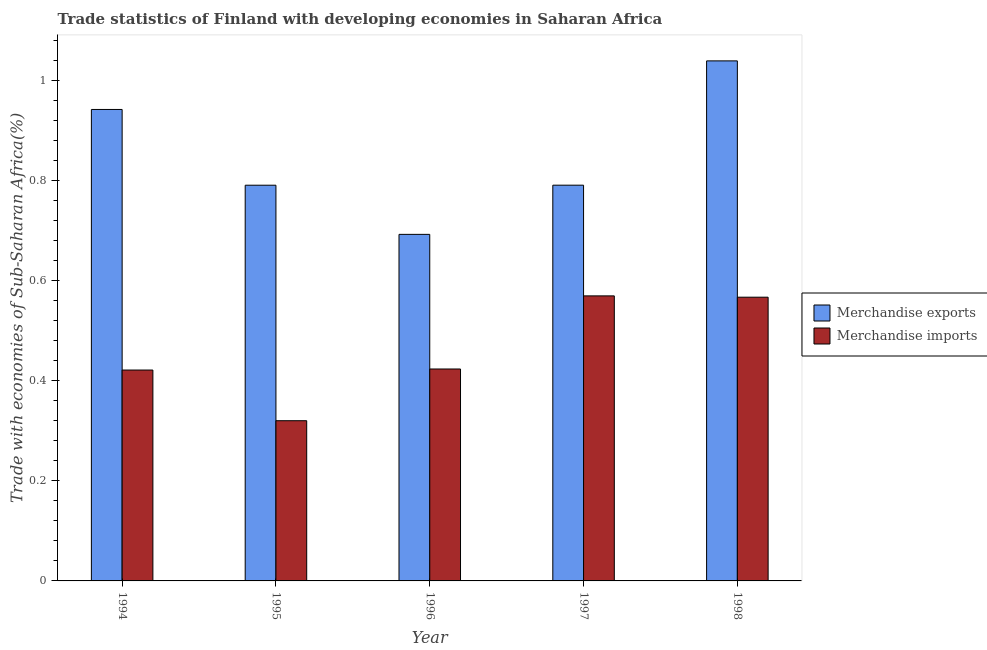How many different coloured bars are there?
Offer a terse response. 2. Are the number of bars on each tick of the X-axis equal?
Offer a very short reply. Yes. How many bars are there on the 4th tick from the right?
Your answer should be very brief. 2. What is the label of the 4th group of bars from the left?
Your response must be concise. 1997. What is the merchandise exports in 1996?
Make the answer very short. 0.69. Across all years, what is the maximum merchandise exports?
Your answer should be very brief. 1.04. Across all years, what is the minimum merchandise exports?
Your answer should be very brief. 0.69. What is the total merchandise imports in the graph?
Offer a terse response. 2.3. What is the difference between the merchandise exports in 1994 and that in 1996?
Provide a short and direct response. 0.25. What is the difference between the merchandise exports in 1996 and the merchandise imports in 1994?
Give a very brief answer. -0.25. What is the average merchandise exports per year?
Offer a terse response. 0.85. What is the ratio of the merchandise imports in 1995 to that in 1997?
Give a very brief answer. 0.56. Is the difference between the merchandise imports in 1994 and 1996 greater than the difference between the merchandise exports in 1994 and 1996?
Offer a very short reply. No. What is the difference between the highest and the second highest merchandise imports?
Offer a terse response. 0. What is the difference between the highest and the lowest merchandise exports?
Your response must be concise. 0.35. In how many years, is the merchandise imports greater than the average merchandise imports taken over all years?
Ensure brevity in your answer.  2. Is the sum of the merchandise imports in 1994 and 1996 greater than the maximum merchandise exports across all years?
Your answer should be very brief. Yes. What does the 2nd bar from the left in 1997 represents?
Keep it short and to the point. Merchandise imports. How many bars are there?
Keep it short and to the point. 10. How many years are there in the graph?
Your answer should be very brief. 5. Where does the legend appear in the graph?
Your answer should be very brief. Center right. How many legend labels are there?
Your answer should be very brief. 2. How are the legend labels stacked?
Give a very brief answer. Vertical. What is the title of the graph?
Provide a succinct answer. Trade statistics of Finland with developing economies in Saharan Africa. Does "constant 2005 US$" appear as one of the legend labels in the graph?
Your answer should be very brief. No. What is the label or title of the X-axis?
Make the answer very short. Year. What is the label or title of the Y-axis?
Ensure brevity in your answer.  Trade with economies of Sub-Saharan Africa(%). What is the Trade with economies of Sub-Saharan Africa(%) of Merchandise exports in 1994?
Your response must be concise. 0.94. What is the Trade with economies of Sub-Saharan Africa(%) of Merchandise imports in 1994?
Your answer should be very brief. 0.42. What is the Trade with economies of Sub-Saharan Africa(%) in Merchandise exports in 1995?
Your answer should be compact. 0.79. What is the Trade with economies of Sub-Saharan Africa(%) of Merchandise imports in 1995?
Your answer should be compact. 0.32. What is the Trade with economies of Sub-Saharan Africa(%) of Merchandise exports in 1996?
Ensure brevity in your answer.  0.69. What is the Trade with economies of Sub-Saharan Africa(%) in Merchandise imports in 1996?
Your answer should be very brief. 0.42. What is the Trade with economies of Sub-Saharan Africa(%) of Merchandise exports in 1997?
Your response must be concise. 0.79. What is the Trade with economies of Sub-Saharan Africa(%) of Merchandise imports in 1997?
Make the answer very short. 0.57. What is the Trade with economies of Sub-Saharan Africa(%) of Merchandise exports in 1998?
Give a very brief answer. 1.04. What is the Trade with economies of Sub-Saharan Africa(%) of Merchandise imports in 1998?
Ensure brevity in your answer.  0.57. Across all years, what is the maximum Trade with economies of Sub-Saharan Africa(%) in Merchandise exports?
Provide a short and direct response. 1.04. Across all years, what is the maximum Trade with economies of Sub-Saharan Africa(%) of Merchandise imports?
Your response must be concise. 0.57. Across all years, what is the minimum Trade with economies of Sub-Saharan Africa(%) in Merchandise exports?
Your answer should be compact. 0.69. Across all years, what is the minimum Trade with economies of Sub-Saharan Africa(%) in Merchandise imports?
Offer a terse response. 0.32. What is the total Trade with economies of Sub-Saharan Africa(%) of Merchandise exports in the graph?
Offer a terse response. 4.26. What is the total Trade with economies of Sub-Saharan Africa(%) of Merchandise imports in the graph?
Ensure brevity in your answer.  2.3. What is the difference between the Trade with economies of Sub-Saharan Africa(%) of Merchandise exports in 1994 and that in 1995?
Give a very brief answer. 0.15. What is the difference between the Trade with economies of Sub-Saharan Africa(%) in Merchandise imports in 1994 and that in 1995?
Provide a short and direct response. 0.1. What is the difference between the Trade with economies of Sub-Saharan Africa(%) in Merchandise exports in 1994 and that in 1996?
Offer a very short reply. 0.25. What is the difference between the Trade with economies of Sub-Saharan Africa(%) of Merchandise imports in 1994 and that in 1996?
Your response must be concise. -0. What is the difference between the Trade with economies of Sub-Saharan Africa(%) in Merchandise exports in 1994 and that in 1997?
Keep it short and to the point. 0.15. What is the difference between the Trade with economies of Sub-Saharan Africa(%) of Merchandise imports in 1994 and that in 1997?
Offer a terse response. -0.15. What is the difference between the Trade with economies of Sub-Saharan Africa(%) in Merchandise exports in 1994 and that in 1998?
Offer a terse response. -0.1. What is the difference between the Trade with economies of Sub-Saharan Africa(%) of Merchandise imports in 1994 and that in 1998?
Your answer should be very brief. -0.15. What is the difference between the Trade with economies of Sub-Saharan Africa(%) of Merchandise exports in 1995 and that in 1996?
Ensure brevity in your answer.  0.1. What is the difference between the Trade with economies of Sub-Saharan Africa(%) of Merchandise imports in 1995 and that in 1996?
Make the answer very short. -0.1. What is the difference between the Trade with economies of Sub-Saharan Africa(%) in Merchandise exports in 1995 and that in 1997?
Your response must be concise. -0. What is the difference between the Trade with economies of Sub-Saharan Africa(%) in Merchandise imports in 1995 and that in 1997?
Provide a succinct answer. -0.25. What is the difference between the Trade with economies of Sub-Saharan Africa(%) of Merchandise exports in 1995 and that in 1998?
Provide a succinct answer. -0.25. What is the difference between the Trade with economies of Sub-Saharan Africa(%) of Merchandise imports in 1995 and that in 1998?
Your answer should be very brief. -0.25. What is the difference between the Trade with economies of Sub-Saharan Africa(%) of Merchandise exports in 1996 and that in 1997?
Your answer should be compact. -0.1. What is the difference between the Trade with economies of Sub-Saharan Africa(%) in Merchandise imports in 1996 and that in 1997?
Give a very brief answer. -0.15. What is the difference between the Trade with economies of Sub-Saharan Africa(%) in Merchandise exports in 1996 and that in 1998?
Your answer should be compact. -0.35. What is the difference between the Trade with economies of Sub-Saharan Africa(%) in Merchandise imports in 1996 and that in 1998?
Make the answer very short. -0.14. What is the difference between the Trade with economies of Sub-Saharan Africa(%) of Merchandise exports in 1997 and that in 1998?
Your response must be concise. -0.25. What is the difference between the Trade with economies of Sub-Saharan Africa(%) of Merchandise imports in 1997 and that in 1998?
Offer a very short reply. 0. What is the difference between the Trade with economies of Sub-Saharan Africa(%) of Merchandise exports in 1994 and the Trade with economies of Sub-Saharan Africa(%) of Merchandise imports in 1995?
Make the answer very short. 0.62. What is the difference between the Trade with economies of Sub-Saharan Africa(%) in Merchandise exports in 1994 and the Trade with economies of Sub-Saharan Africa(%) in Merchandise imports in 1996?
Give a very brief answer. 0.52. What is the difference between the Trade with economies of Sub-Saharan Africa(%) in Merchandise exports in 1994 and the Trade with economies of Sub-Saharan Africa(%) in Merchandise imports in 1997?
Your answer should be very brief. 0.37. What is the difference between the Trade with economies of Sub-Saharan Africa(%) in Merchandise exports in 1994 and the Trade with economies of Sub-Saharan Africa(%) in Merchandise imports in 1998?
Offer a terse response. 0.38. What is the difference between the Trade with economies of Sub-Saharan Africa(%) in Merchandise exports in 1995 and the Trade with economies of Sub-Saharan Africa(%) in Merchandise imports in 1996?
Your response must be concise. 0.37. What is the difference between the Trade with economies of Sub-Saharan Africa(%) of Merchandise exports in 1995 and the Trade with economies of Sub-Saharan Africa(%) of Merchandise imports in 1997?
Offer a terse response. 0.22. What is the difference between the Trade with economies of Sub-Saharan Africa(%) in Merchandise exports in 1995 and the Trade with economies of Sub-Saharan Africa(%) in Merchandise imports in 1998?
Make the answer very short. 0.22. What is the difference between the Trade with economies of Sub-Saharan Africa(%) of Merchandise exports in 1996 and the Trade with economies of Sub-Saharan Africa(%) of Merchandise imports in 1997?
Your answer should be compact. 0.12. What is the difference between the Trade with economies of Sub-Saharan Africa(%) of Merchandise exports in 1996 and the Trade with economies of Sub-Saharan Africa(%) of Merchandise imports in 1998?
Your response must be concise. 0.13. What is the difference between the Trade with economies of Sub-Saharan Africa(%) in Merchandise exports in 1997 and the Trade with economies of Sub-Saharan Africa(%) in Merchandise imports in 1998?
Make the answer very short. 0.22. What is the average Trade with economies of Sub-Saharan Africa(%) in Merchandise exports per year?
Provide a succinct answer. 0.85. What is the average Trade with economies of Sub-Saharan Africa(%) in Merchandise imports per year?
Offer a terse response. 0.46. In the year 1994, what is the difference between the Trade with economies of Sub-Saharan Africa(%) in Merchandise exports and Trade with economies of Sub-Saharan Africa(%) in Merchandise imports?
Offer a terse response. 0.52. In the year 1995, what is the difference between the Trade with economies of Sub-Saharan Africa(%) of Merchandise exports and Trade with economies of Sub-Saharan Africa(%) of Merchandise imports?
Offer a terse response. 0.47. In the year 1996, what is the difference between the Trade with economies of Sub-Saharan Africa(%) in Merchandise exports and Trade with economies of Sub-Saharan Africa(%) in Merchandise imports?
Your answer should be very brief. 0.27. In the year 1997, what is the difference between the Trade with economies of Sub-Saharan Africa(%) in Merchandise exports and Trade with economies of Sub-Saharan Africa(%) in Merchandise imports?
Keep it short and to the point. 0.22. In the year 1998, what is the difference between the Trade with economies of Sub-Saharan Africa(%) in Merchandise exports and Trade with economies of Sub-Saharan Africa(%) in Merchandise imports?
Your response must be concise. 0.47. What is the ratio of the Trade with economies of Sub-Saharan Africa(%) in Merchandise exports in 1994 to that in 1995?
Your answer should be compact. 1.19. What is the ratio of the Trade with economies of Sub-Saharan Africa(%) in Merchandise imports in 1994 to that in 1995?
Make the answer very short. 1.32. What is the ratio of the Trade with economies of Sub-Saharan Africa(%) in Merchandise exports in 1994 to that in 1996?
Your answer should be compact. 1.36. What is the ratio of the Trade with economies of Sub-Saharan Africa(%) in Merchandise exports in 1994 to that in 1997?
Offer a very short reply. 1.19. What is the ratio of the Trade with economies of Sub-Saharan Africa(%) of Merchandise imports in 1994 to that in 1997?
Your response must be concise. 0.74. What is the ratio of the Trade with economies of Sub-Saharan Africa(%) in Merchandise exports in 1994 to that in 1998?
Keep it short and to the point. 0.91. What is the ratio of the Trade with economies of Sub-Saharan Africa(%) in Merchandise imports in 1994 to that in 1998?
Offer a very short reply. 0.74. What is the ratio of the Trade with economies of Sub-Saharan Africa(%) of Merchandise exports in 1995 to that in 1996?
Give a very brief answer. 1.14. What is the ratio of the Trade with economies of Sub-Saharan Africa(%) in Merchandise imports in 1995 to that in 1996?
Offer a very short reply. 0.76. What is the ratio of the Trade with economies of Sub-Saharan Africa(%) in Merchandise exports in 1995 to that in 1997?
Your response must be concise. 1. What is the ratio of the Trade with economies of Sub-Saharan Africa(%) in Merchandise imports in 1995 to that in 1997?
Keep it short and to the point. 0.56. What is the ratio of the Trade with economies of Sub-Saharan Africa(%) in Merchandise exports in 1995 to that in 1998?
Keep it short and to the point. 0.76. What is the ratio of the Trade with economies of Sub-Saharan Africa(%) of Merchandise imports in 1995 to that in 1998?
Offer a terse response. 0.56. What is the ratio of the Trade with economies of Sub-Saharan Africa(%) in Merchandise exports in 1996 to that in 1997?
Keep it short and to the point. 0.88. What is the ratio of the Trade with economies of Sub-Saharan Africa(%) of Merchandise imports in 1996 to that in 1997?
Your answer should be compact. 0.74. What is the ratio of the Trade with economies of Sub-Saharan Africa(%) in Merchandise exports in 1996 to that in 1998?
Your answer should be very brief. 0.67. What is the ratio of the Trade with economies of Sub-Saharan Africa(%) of Merchandise imports in 1996 to that in 1998?
Offer a terse response. 0.75. What is the ratio of the Trade with economies of Sub-Saharan Africa(%) in Merchandise exports in 1997 to that in 1998?
Your answer should be very brief. 0.76. What is the ratio of the Trade with economies of Sub-Saharan Africa(%) in Merchandise imports in 1997 to that in 1998?
Give a very brief answer. 1. What is the difference between the highest and the second highest Trade with economies of Sub-Saharan Africa(%) of Merchandise exports?
Your answer should be very brief. 0.1. What is the difference between the highest and the second highest Trade with economies of Sub-Saharan Africa(%) of Merchandise imports?
Make the answer very short. 0. What is the difference between the highest and the lowest Trade with economies of Sub-Saharan Africa(%) of Merchandise exports?
Your response must be concise. 0.35. What is the difference between the highest and the lowest Trade with economies of Sub-Saharan Africa(%) in Merchandise imports?
Your response must be concise. 0.25. 